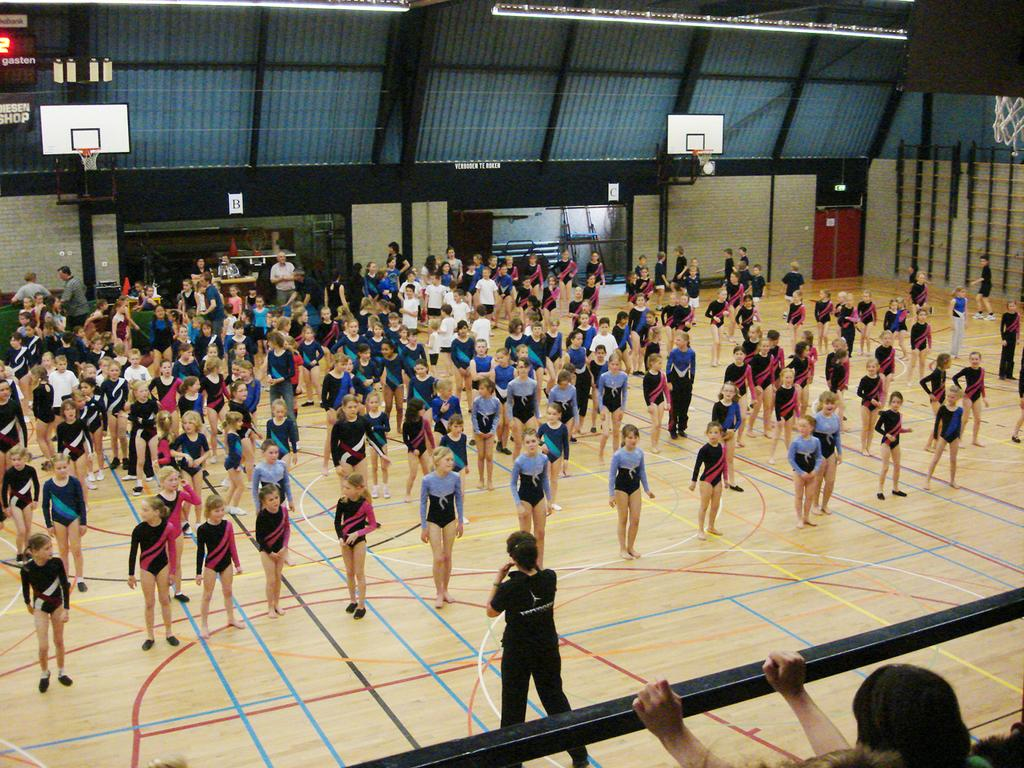Who or what can be seen in the image? There are people in the image. What objects are present in the image? There are hoops and a rod at the bottom of the image. What architectural feature is visible in the image? There is a door in the image. What can be seen at the top of the image? There are lights at the top of the image. What type of disease is affecting the people in the image? There is no indication of any disease affecting the people in the image. Can you describe the cloud formation in the image? There is no cloud formation present in the image. 